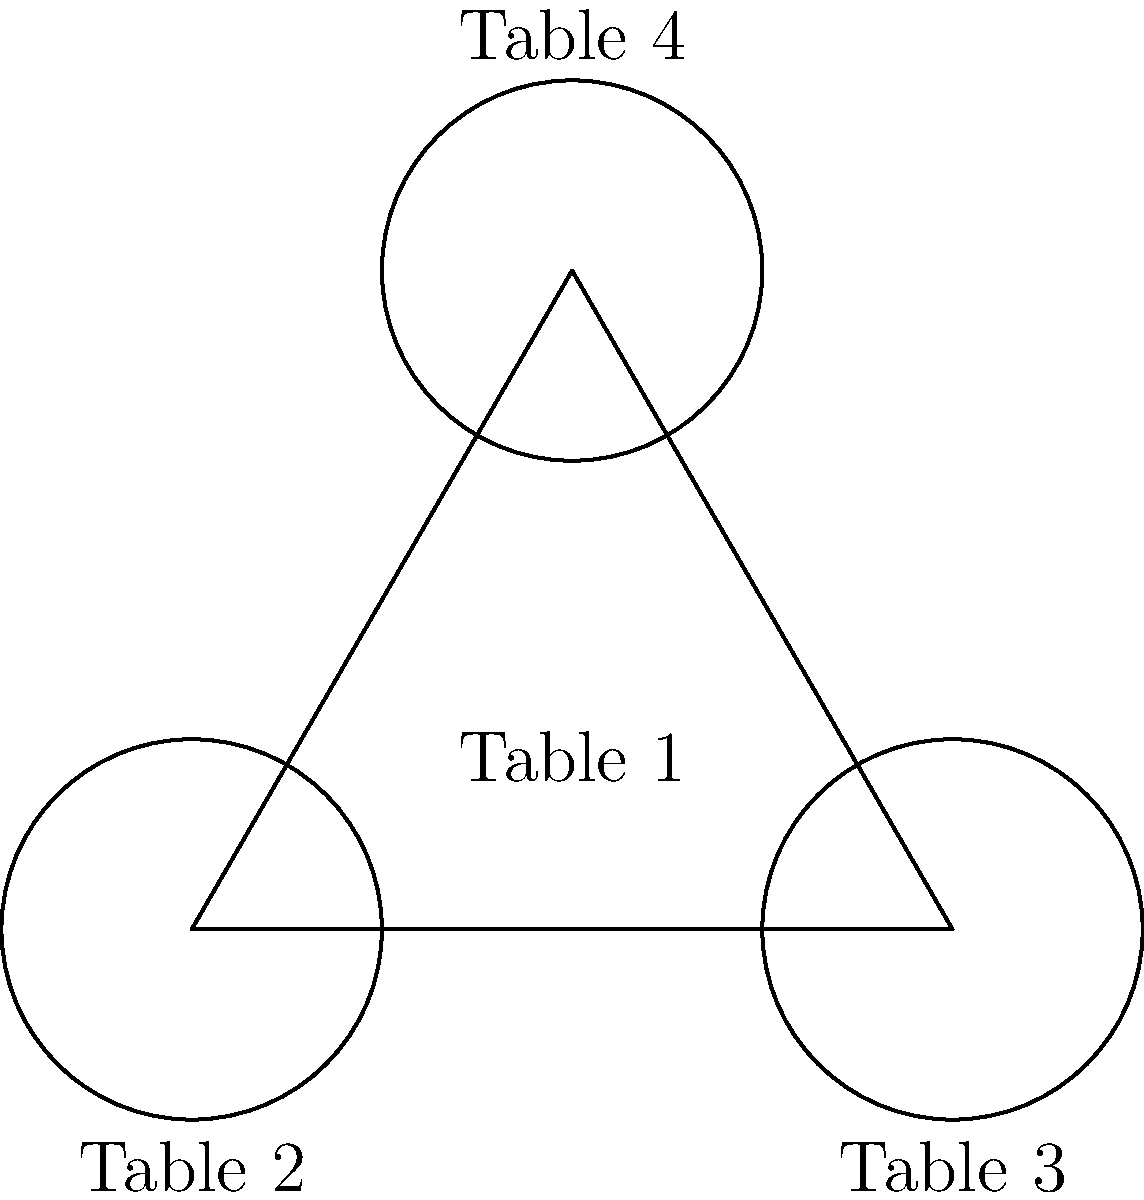As a charity event organizer, you're planning a gala dinner for high-profile donors. You decide to arrange the seating using an equilateral triangle formation with circular tables. The side length of the triangle is 4 meters, and each circular table has a diameter of 2 meters. If you place one table at each vertex of the triangle and one table in the center, what is the maximum number of guests that can be seated if each table comfortably seats 8 people? Let's approach this step-by-step:

1) First, we need to determine if all four tables can fit within the given arrangement:
   - The triangle has a side length of 4 meters.
   - Each table has a diameter of 2 meters (radius of 1 meter).
   - Tables are placed at each vertex and in the center.

2) For an equilateral triangle with side length $a$, the height $h$ is given by:
   $h = \frac{\sqrt{3}}{2}a = \frac{\sqrt{3}}{2} \cdot 4 = 2\sqrt{3} \approx 3.464$ meters

3) The center of the triangle is located at $(2, \frac{\sqrt{3}}{3})$ relative to the base.
   This point is equidistant from all vertices, with a distance of:
   $\frac{2\sqrt{3}}{3} \approx 1.155$ meters

4) Since 1.155 meters > 1 meter (the radius of each table), we can confirm that all four tables fit without overlapping.

5) Given that each table can comfortably seat 8 people:
   Total number of guests = Number of tables × Guests per table
                          = 4 × 8 = 32 guests

Therefore, the maximum number of guests that can be seated is 32.
Answer: 32 guests 